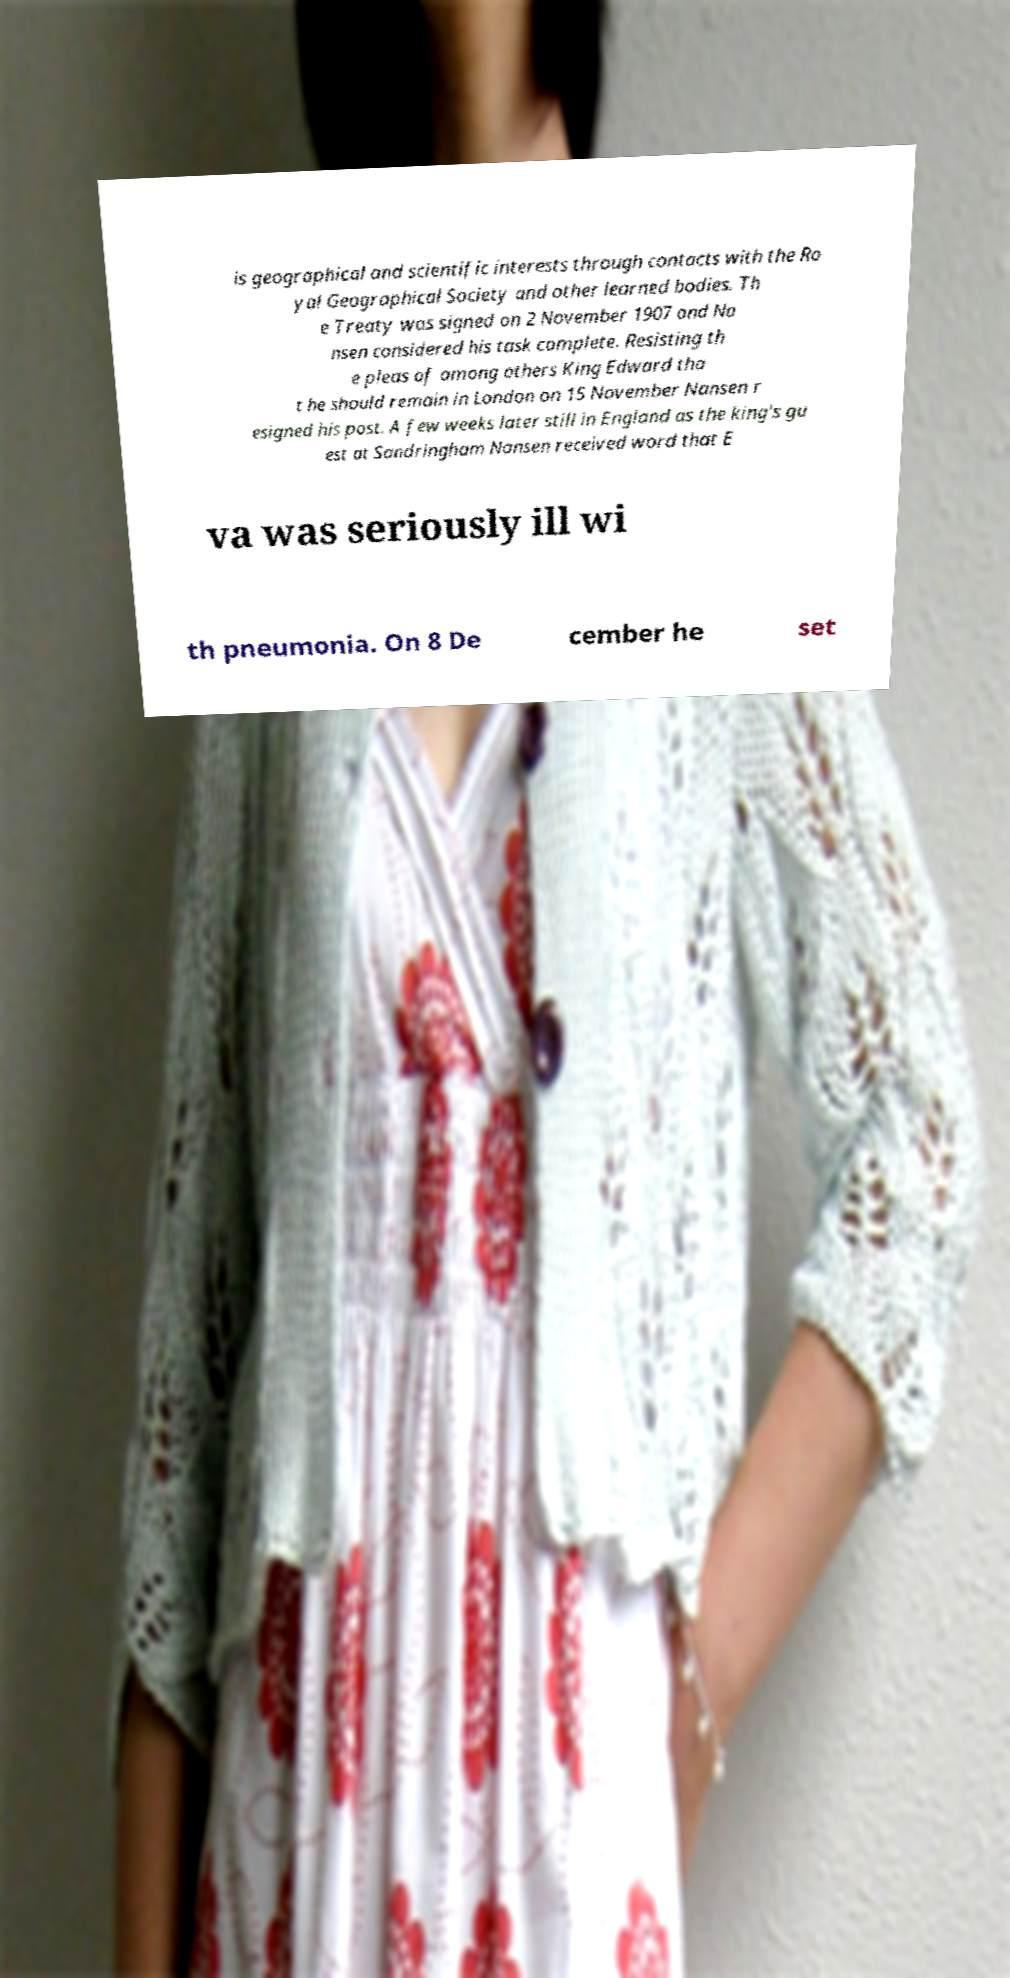Please identify and transcribe the text found in this image. is geographical and scientific interests through contacts with the Ro yal Geographical Society and other learned bodies. Th e Treaty was signed on 2 November 1907 and Na nsen considered his task complete. Resisting th e pleas of among others King Edward tha t he should remain in London on 15 November Nansen r esigned his post. A few weeks later still in England as the king's gu est at Sandringham Nansen received word that E va was seriously ill wi th pneumonia. On 8 De cember he set 